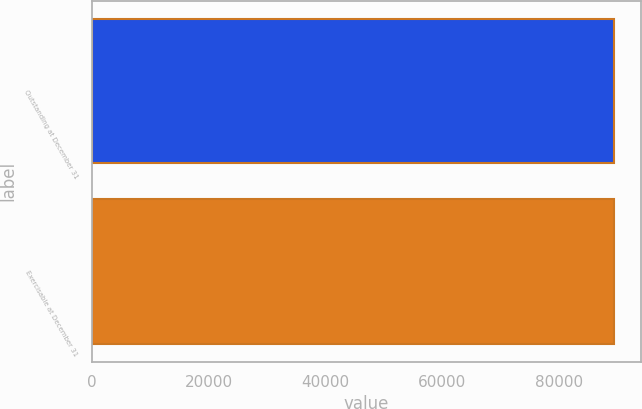Convert chart. <chart><loc_0><loc_0><loc_500><loc_500><bar_chart><fcel>Outstanding at December 31<fcel>Exercisable at December 31<nl><fcel>89500.3<fcel>89500.4<nl></chart> 